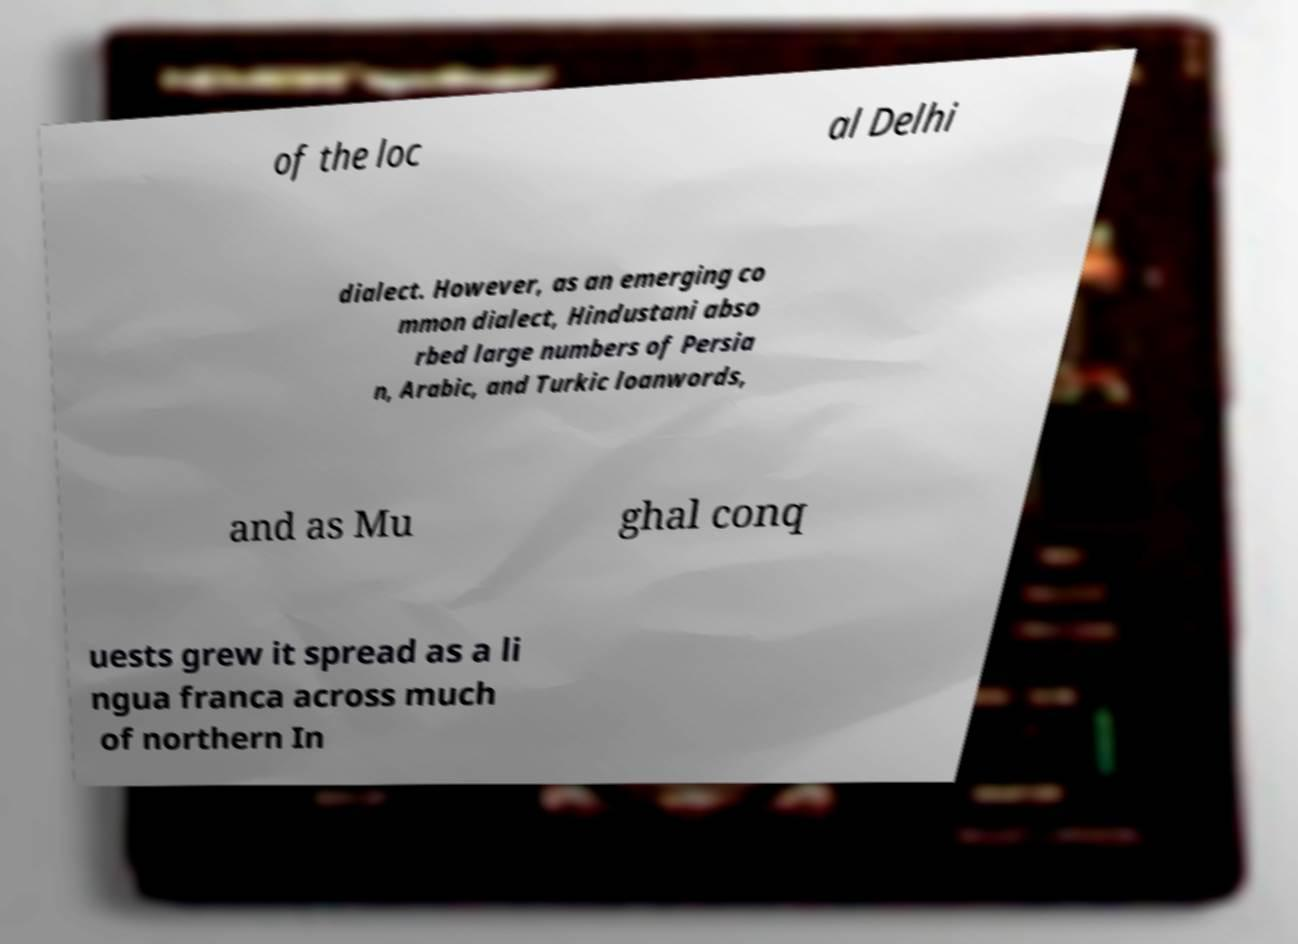Could you extract and type out the text from this image? of the loc al Delhi dialect. However, as an emerging co mmon dialect, Hindustani abso rbed large numbers of Persia n, Arabic, and Turkic loanwords, and as Mu ghal conq uests grew it spread as a li ngua franca across much of northern In 